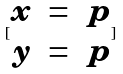Convert formula to latex. <formula><loc_0><loc_0><loc_500><loc_500>[ \begin{matrix} x & = & p \\ y & = & p \end{matrix} ]</formula> 